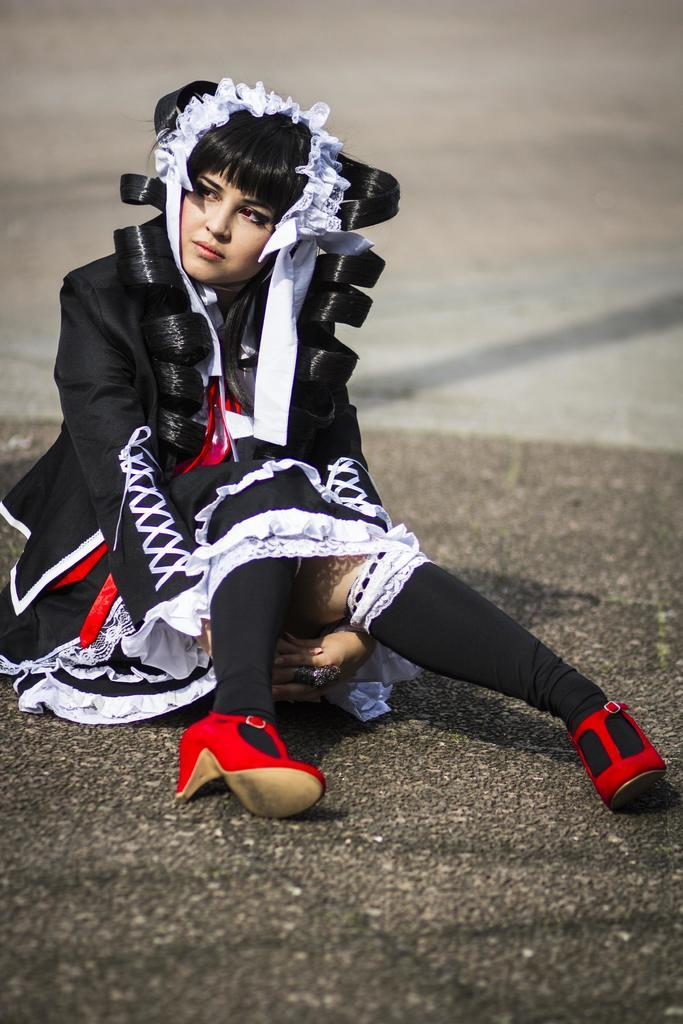Who is present in the image? There is a woman in the image. What is the woman doing in the image? The woman is sitting on the road. What type of coal is the woman using to whip the street in the image? There is no coal or whip present in the image. The woman is simply sitting on the road. 